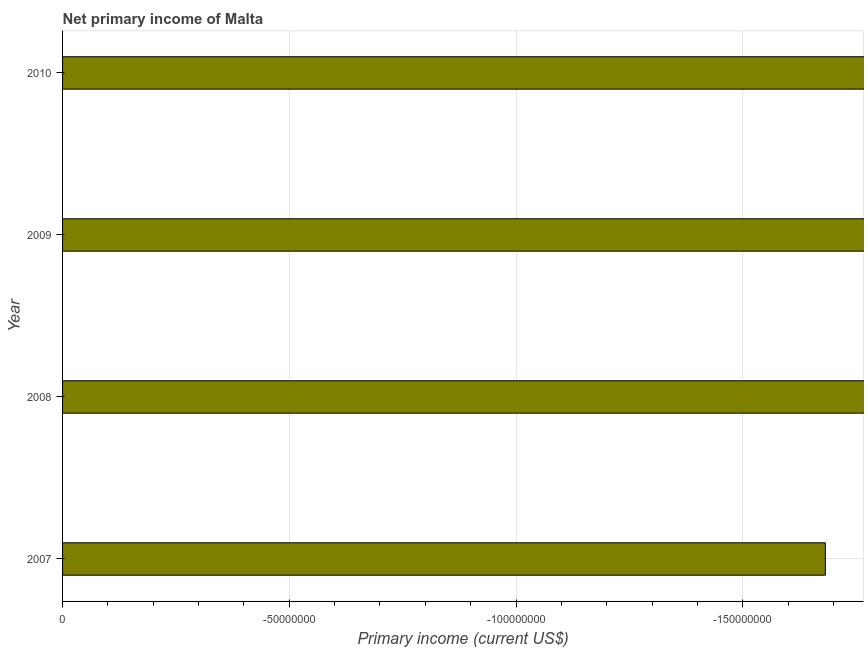Does the graph contain grids?
Your answer should be compact. Yes. What is the title of the graph?
Offer a very short reply. Net primary income of Malta. What is the label or title of the X-axis?
Your answer should be very brief. Primary income (current US$). What is the label or title of the Y-axis?
Give a very brief answer. Year. What is the average amount of primary income per year?
Provide a succinct answer. 0. In how many years, is the amount of primary income greater than the average amount of primary income taken over all years?
Make the answer very short. 0. How many bars are there?
Your response must be concise. 0. How many years are there in the graph?
Your response must be concise. 4. Are the values on the major ticks of X-axis written in scientific E-notation?
Provide a succinct answer. No. What is the Primary income (current US$) in 2008?
Ensure brevity in your answer.  0. What is the Primary income (current US$) in 2010?
Provide a succinct answer. 0. 